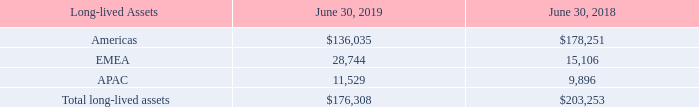12. Information about Segments of Geographic Areas
The Company operates in one segment, the development and marketing of network infrastructure equipment. Revenue is attributed to a geographical area based on the location of the customers. The Company operates in three geographic theaters: Americas, which includes the United States, Canada, Mexico, Central America and South America; EMEA, which includes Europe, Russia, Middle East and Africa; and APAC which includes Asia Pacific, China, South Asia and Japan. The Company’s chief operating decision maker (“CODM”), who is its CEO, reviews financial information presented on a consolidated basis for purposes of allocating resources and evaluating financial performance.
See Note 3. Revenues for the Company’s revenues by geographic regions and channel based on the customers’ ship-to location.
The Company’s long-lived assets are attributed to the geographic regions as follows (in thousands):
What does the region of Americas include? United states, canada, mexico, central america, south america. Which years does the table provide information for the company's long-lived assets are attributed to the geographic regions? 2019, 2018. What was the amount of Total long-lived assets in 2019?
Answer scale should be: thousand. 176,308. How many years did long-lived assets from Americas exceed $150,000 thousand? 2018
Answer: 1. What was the change in the long-lived assets from APAC between 2018 and 2019?
Answer scale should be: thousand. 11,529-9,896
Answer: 1633. What was the percentage change in total long-lived assets between 2018 and 2019?
Answer scale should be: percent. (176,308-203,253)/203,253
Answer: -13.26. 